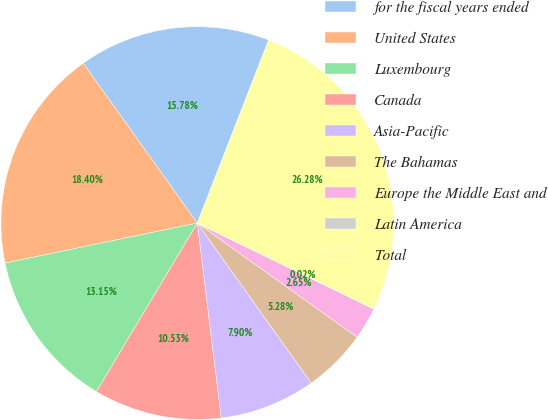Convert chart to OTSL. <chart><loc_0><loc_0><loc_500><loc_500><pie_chart><fcel>for the fiscal years ended<fcel>United States<fcel>Luxembourg<fcel>Canada<fcel>Asia-Pacific<fcel>The Bahamas<fcel>Europe the Middle East and<fcel>Latin America<fcel>Total<nl><fcel>15.78%<fcel>18.4%<fcel>13.15%<fcel>10.53%<fcel>7.9%<fcel>5.28%<fcel>2.65%<fcel>0.02%<fcel>26.28%<nl></chart> 